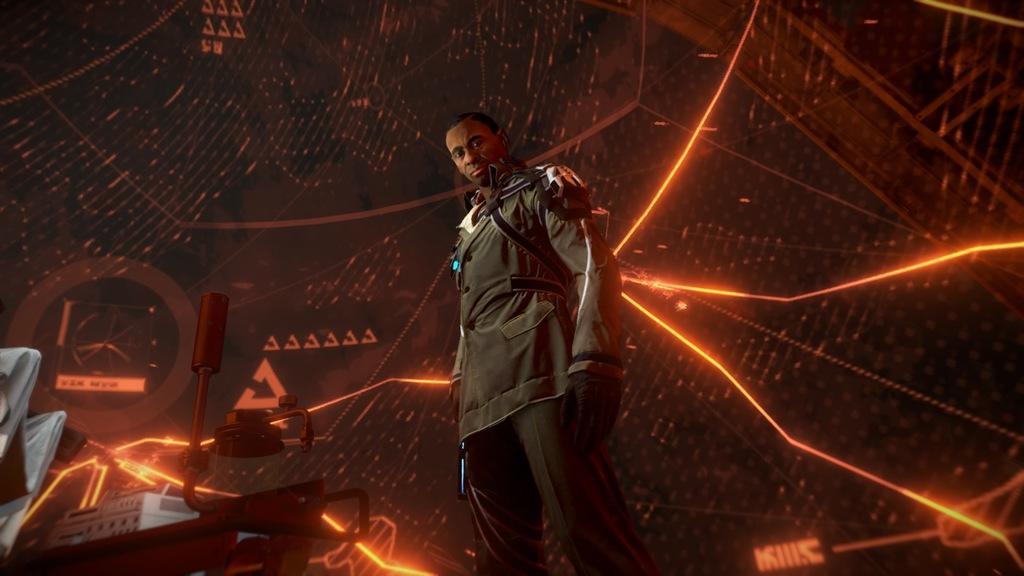Describe this image in one or two sentences. In this image in the middle, there is a man, he wears a jacket, trouser, he is standing. On the left there are some machines, chairs. In the background there is a screen. 